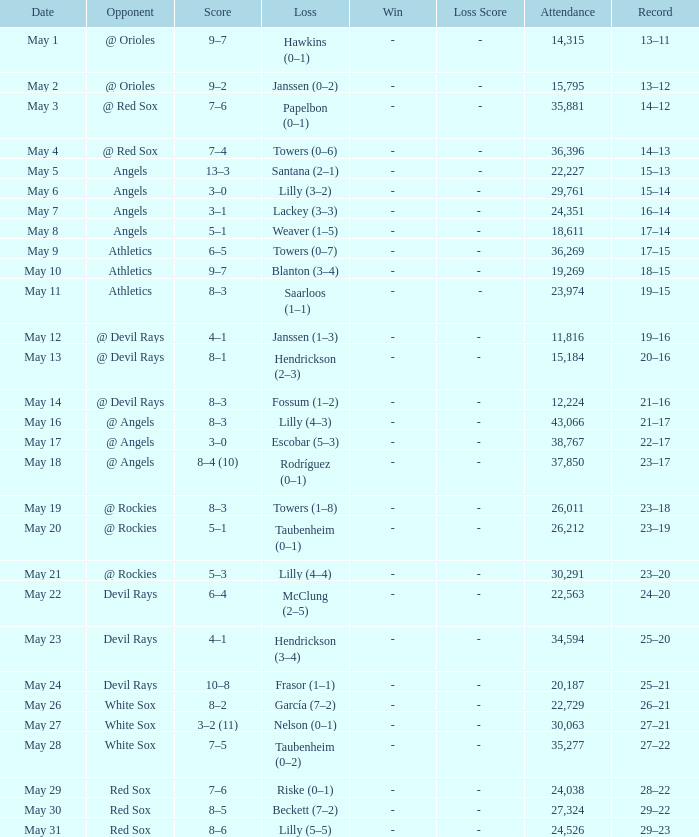What was the overall attendance when the team had a 16-14 record? 1.0. 